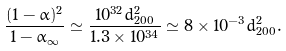<formula> <loc_0><loc_0><loc_500><loc_500>\frac { ( 1 - \alpha ) ^ { 2 } } { 1 - \alpha _ { \infty } } \simeq \frac { 1 0 ^ { 3 2 } d ^ { 2 } _ { 2 0 0 } } { 1 . 3 \times 1 0 ^ { 3 4 } } \simeq 8 \times 1 0 ^ { - 3 } d ^ { 2 } _ { 2 0 0 } .</formula> 